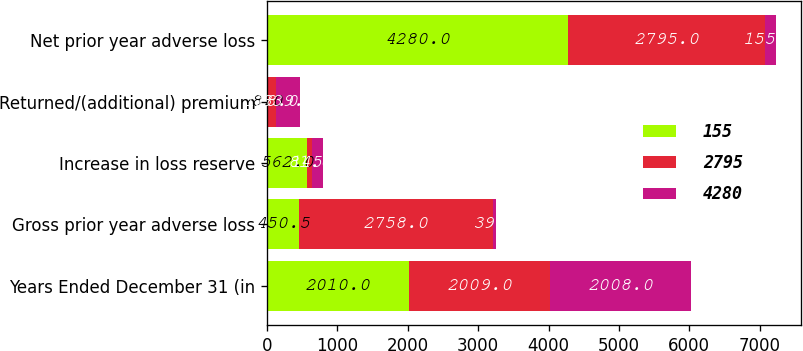Convert chart to OTSL. <chart><loc_0><loc_0><loc_500><loc_500><stacked_bar_chart><ecel><fcel>Years Ended December 31 (in<fcel>Gross prior year adverse loss<fcel>Increase in loss reserve<fcel>Returned/(additional) premium<fcel>Net prior year adverse loss<nl><fcel>155<fcel>2010<fcel>450.5<fcel>562<fcel>8<fcel>4280<nl><fcel>2795<fcel>2009<fcel>2758<fcel>81<fcel>118<fcel>2795<nl><fcel>4280<fcel>2008<fcel>39<fcel>145<fcel>339<fcel>155<nl></chart> 